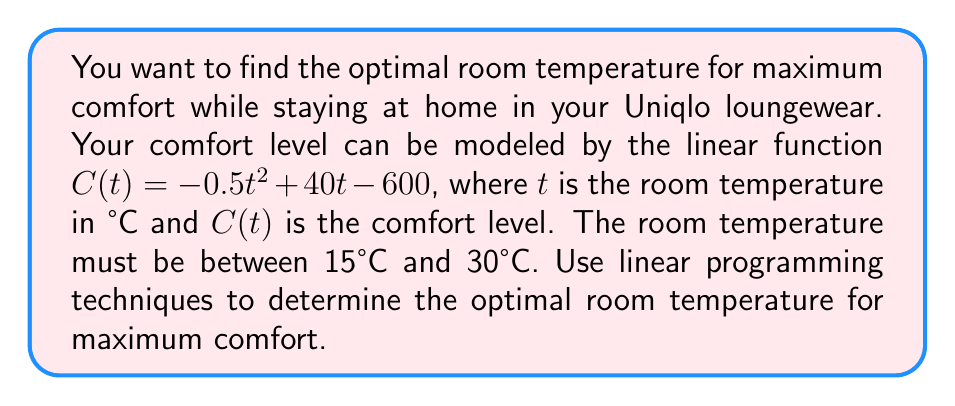What is the answer to this math problem? To solve this problem using linear programming techniques, we'll follow these steps:

1) The objective function is $C(t) = -0.5t^2 + 40t - 600$. However, this is quadratic, not linear. To use linear programming, we need to find the maximum of this function within the given constraints.

2) To find the maximum of a quadratic function, we can use calculus:
   $$\frac{dC}{dt} = -t + 40$$

3) Set this equal to zero to find the critical point:
   $$-t + 40 = 0$$
   $$t = 40$$

4) This critical point (40°C) is outside our constraint range of 15°C to 30°C. In linear programming, when the unconstrained maximum is outside the feasible region, the optimum will occur at one of the constraint boundaries.

5) Let's evaluate $C(t)$ at both ends of our constraint range:

   At $t = 15$: $C(15) = -0.5(15)^2 + 40(15) - 600 = 187.5$
   At $t = 30$: $C(30) = -0.5(30)^2 + 40(30) - 600 = 300$

6) The maximum comfort level within our constraints occurs at $t = 30°C$.

Therefore, the optimal room temperature for maximum comfort is 30°C.
Answer: 30°C 